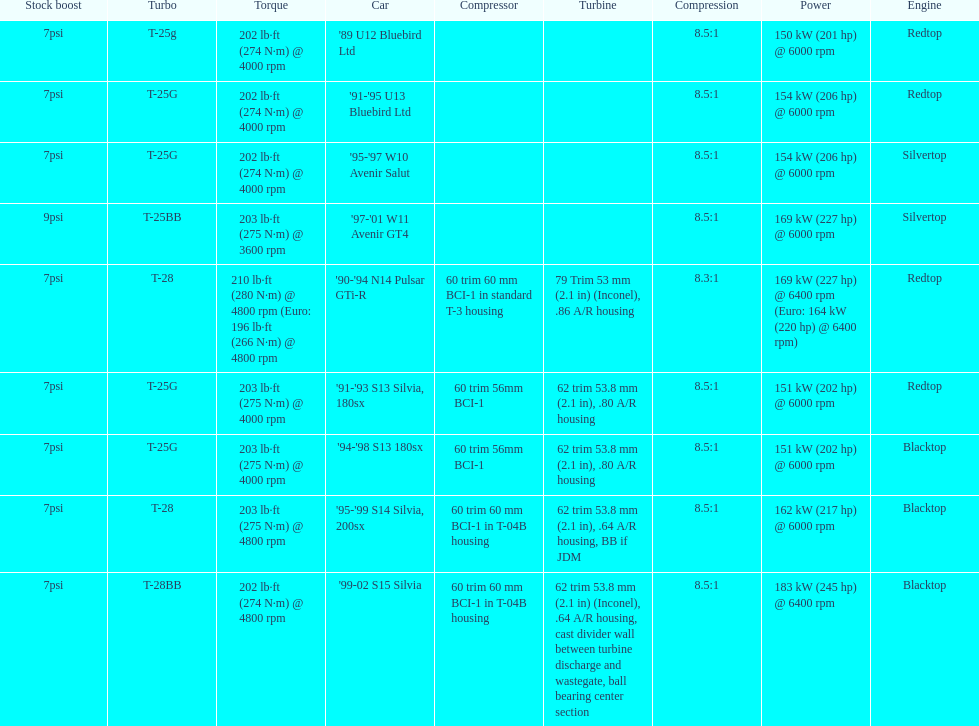Which car's power measured at higher than 6000 rpm? '90-'94 N14 Pulsar GTi-R, '99-02 S15 Silvia. 